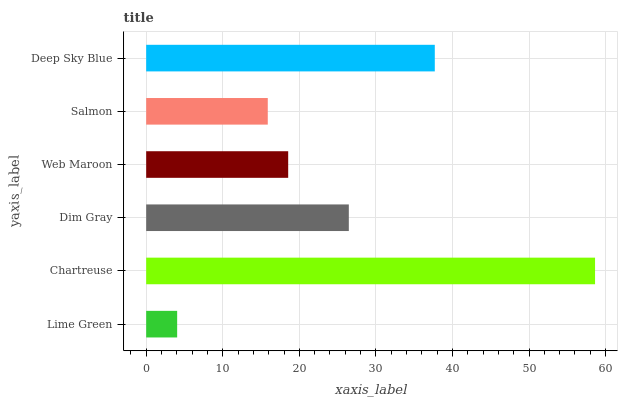Is Lime Green the minimum?
Answer yes or no. Yes. Is Chartreuse the maximum?
Answer yes or no. Yes. Is Dim Gray the minimum?
Answer yes or no. No. Is Dim Gray the maximum?
Answer yes or no. No. Is Chartreuse greater than Dim Gray?
Answer yes or no. Yes. Is Dim Gray less than Chartreuse?
Answer yes or no. Yes. Is Dim Gray greater than Chartreuse?
Answer yes or no. No. Is Chartreuse less than Dim Gray?
Answer yes or no. No. Is Dim Gray the high median?
Answer yes or no. Yes. Is Web Maroon the low median?
Answer yes or no. Yes. Is Salmon the high median?
Answer yes or no. No. Is Deep Sky Blue the low median?
Answer yes or no. No. 